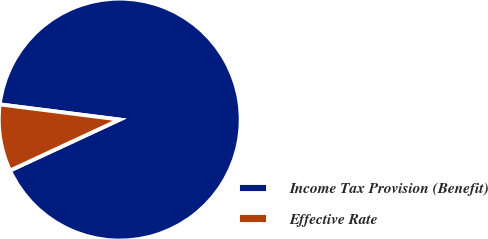Convert chart. <chart><loc_0><loc_0><loc_500><loc_500><pie_chart><fcel>Income Tax Provision (Benefit)<fcel>Effective Rate<nl><fcel>91.07%<fcel>8.93%<nl></chart> 